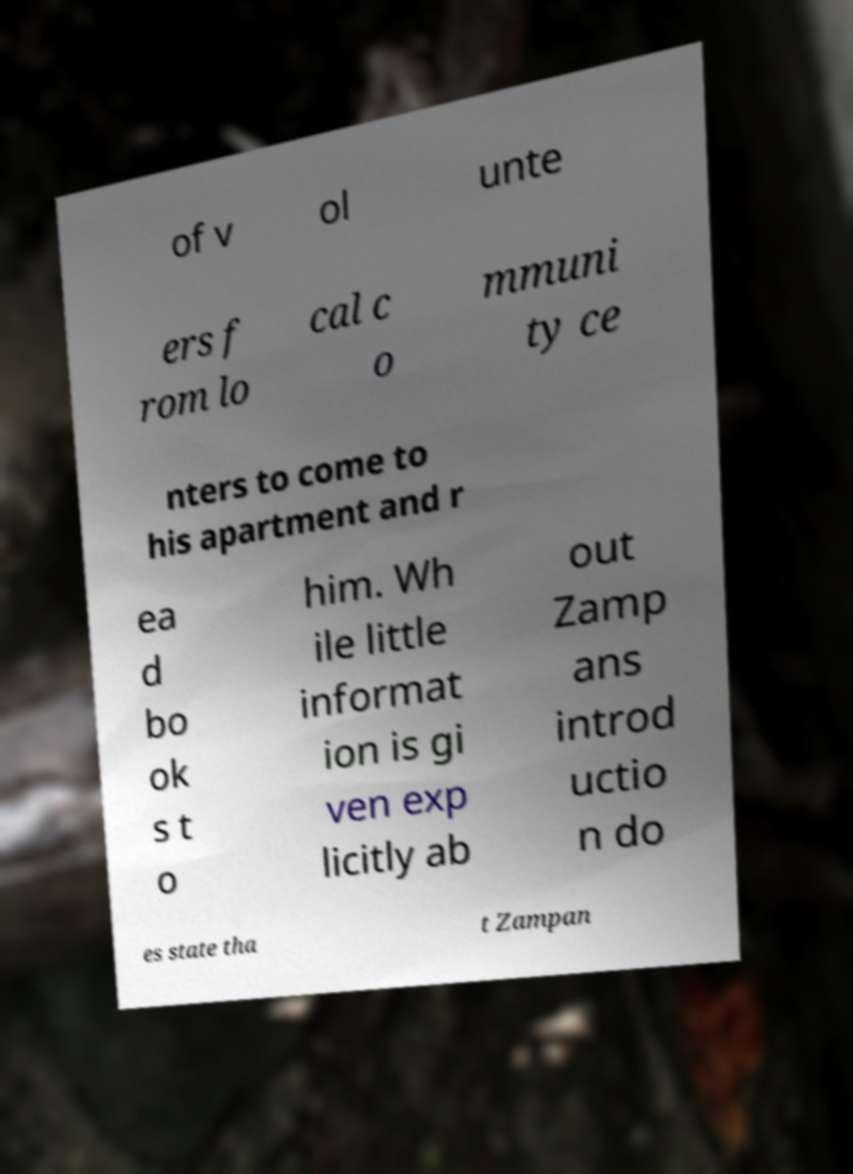Could you extract and type out the text from this image? of v ol unte ers f rom lo cal c o mmuni ty ce nters to come to his apartment and r ea d bo ok s t o him. Wh ile little informat ion is gi ven exp licitly ab out Zamp ans introd uctio n do es state tha t Zampan 